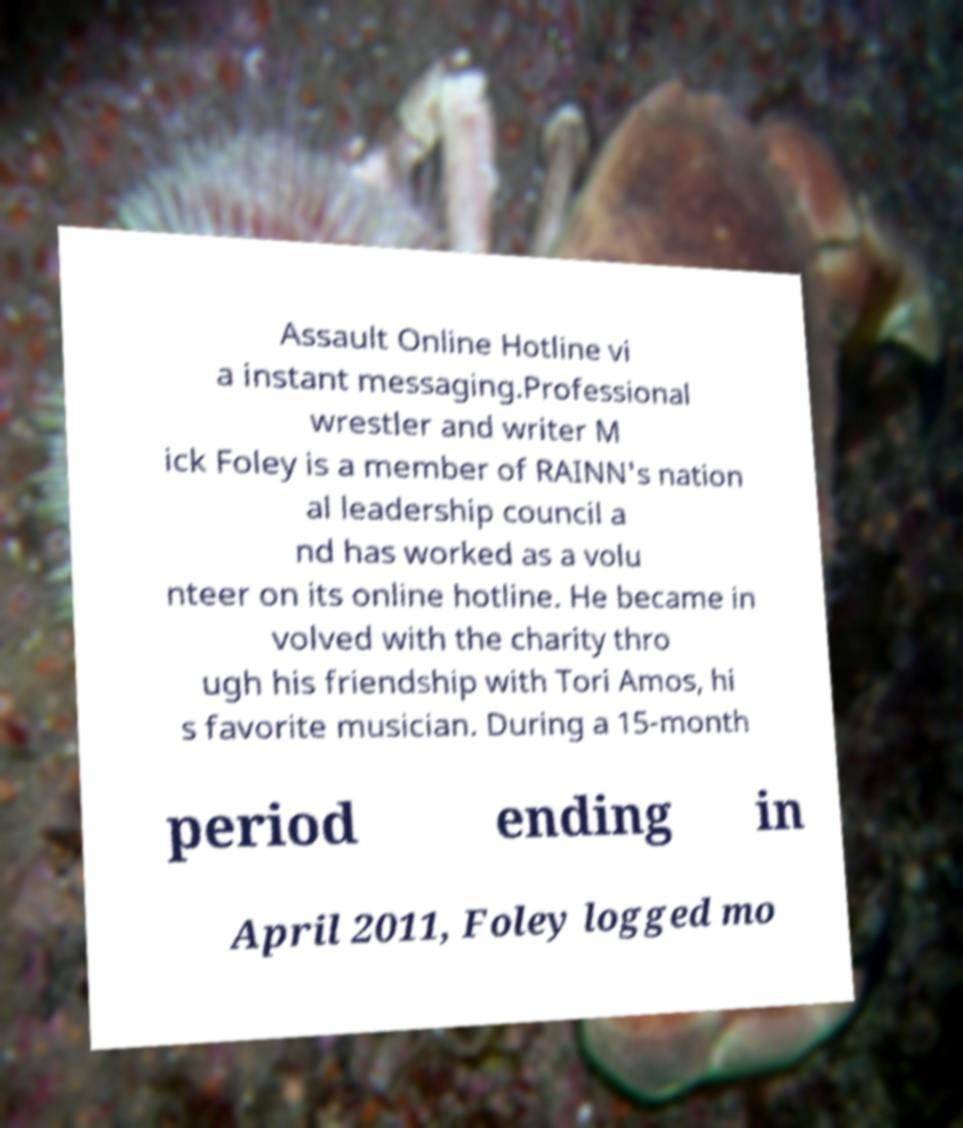Can you accurately transcribe the text from the provided image for me? Assault Online Hotline vi a instant messaging.Professional wrestler and writer M ick Foley is a member of RAINN's nation al leadership council a nd has worked as a volu nteer on its online hotline. He became in volved with the charity thro ugh his friendship with Tori Amos, hi s favorite musician. During a 15-month period ending in April 2011, Foley logged mo 